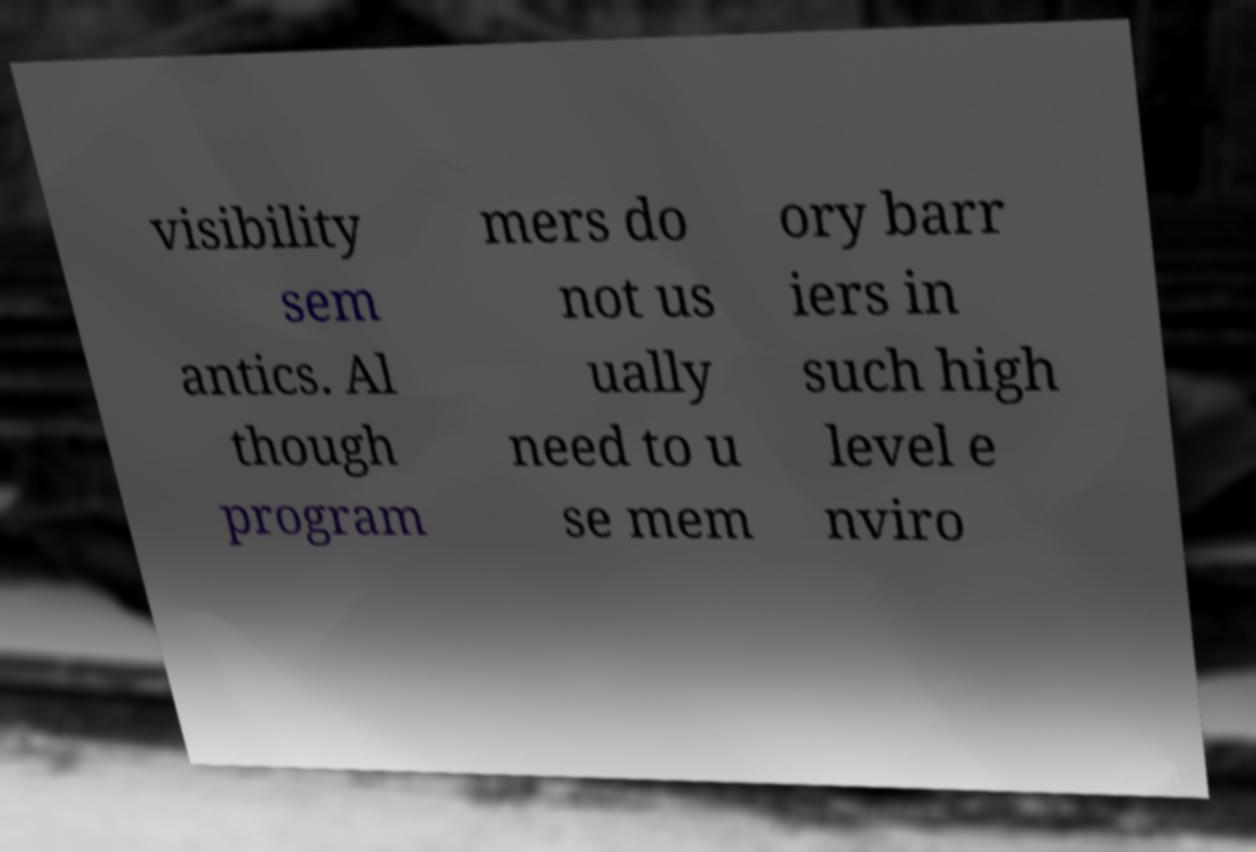Please read and relay the text visible in this image. What does it say? visibility sem antics. Al though program mers do not us ually need to u se mem ory barr iers in such high level e nviro 